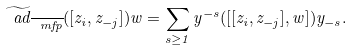Convert formula to latex. <formula><loc_0><loc_0><loc_500><loc_500>\widetilde { \ a d } _ { \overline { \ m f p } } ( [ z _ { i } , z _ { - j } ] ) w = \sum _ { s \geq 1 } y ^ { - s } ( [ [ z _ { i } , z _ { - j } ] , w ] ) y _ { - s } .</formula> 